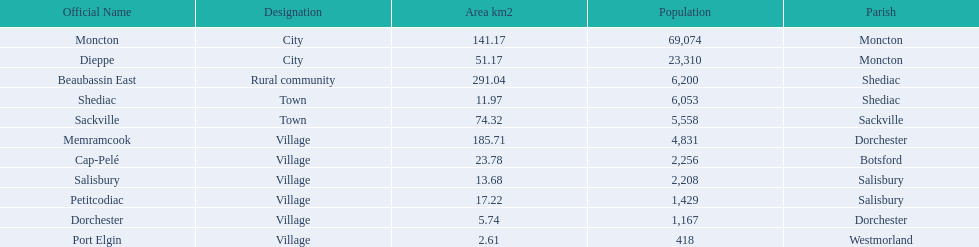The sole countryside community on the list Beaubassin East. 